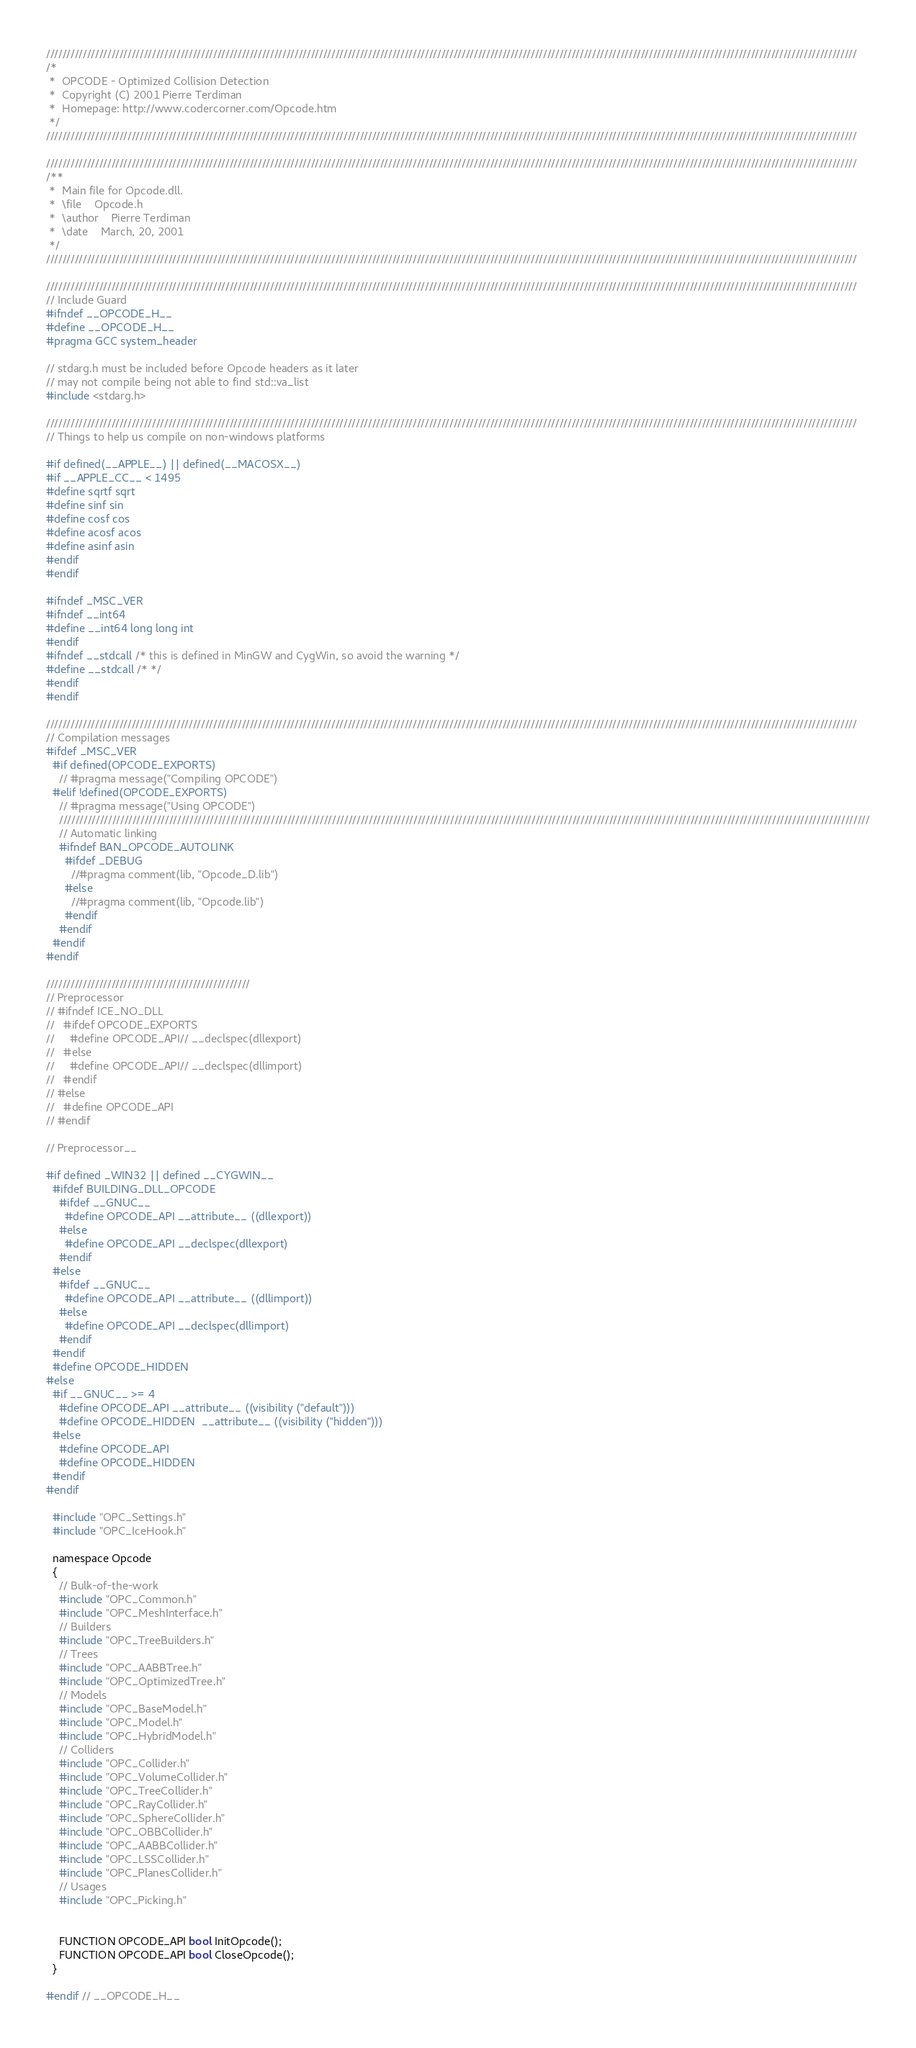Convert code to text. <code><loc_0><loc_0><loc_500><loc_500><_C_>///////////////////////////////////////////////////////////////////////////////////////////////////////////////////////////////////////////////////////////////////////////////////////////////////////
/*
 *  OPCODE - Optimized Collision Detection
 *  Copyright (C) 2001 Pierre Terdiman
 *  Homepage: http://www.codercorner.com/Opcode.htm
 */
///////////////////////////////////////////////////////////////////////////////////////////////////////////////////////////////////////////////////////////////////////////////////////////////////////

///////////////////////////////////////////////////////////////////////////////////////////////////////////////////////////////////////////////////////////////////////////////////////////////////////
/**
 *  Main file for Opcode.dll.
 *  \file    Opcode.h
 *  \author    Pierre Terdiman
 *  \date    March, 20, 2001
 */
///////////////////////////////////////////////////////////////////////////////////////////////////////////////////////////////////////////////////////////////////////////////////////////////////////

///////////////////////////////////////////////////////////////////////////////////////////////////////////////////////////////////////////////////////////////////////////////////////////////////////
// Include Guard
#ifndef __OPCODE_H__
#define __OPCODE_H__
#pragma GCC system_header

// stdarg.h must be included before Opcode headers as it later
// may not compile being not able to find std::va_list
#include <stdarg.h>

///////////////////////////////////////////////////////////////////////////////////////////////////////////////////////////////////////////////////////////////////////////////////////////////////////
// Things to help us compile on non-windows platforms

#if defined(__APPLE__) || defined(__MACOSX__)
#if __APPLE_CC__ < 1495
#define sqrtf sqrt
#define sinf sin
#define cosf cos
#define acosf acos
#define asinf asin
#endif
#endif

#ifndef _MSC_VER
#ifndef __int64
#define __int64 long long int
#endif
#ifndef __stdcall /* this is defined in MinGW and CygWin, so avoid the warning */
#define __stdcall /* */
#endif
#endif

///////////////////////////////////////////////////////////////////////////////////////////////////////////////////////////////////////////////////////////////////////////////////////////////////////
// Compilation messages
#ifdef _MSC_VER
  #if defined(OPCODE_EXPORTS)
    // #pragma message("Compiling OPCODE")
  #elif !defined(OPCODE_EXPORTS)
    // #pragma message("Using OPCODE")
    ///////////////////////////////////////////////////////////////////////////////////////////////////////////////////////////////////////////////////////////////////////////////////////////////////////
    // Automatic linking
    #ifndef BAN_OPCODE_AUTOLINK
      #ifdef _DEBUG
        //#pragma comment(lib, "Opcode_D.lib")
      #else
        //#pragma comment(lib, "Opcode.lib")
      #endif
    #endif
  #endif
#endif

//////////////////////////////////////////////////
// Preprocessor
// #ifndef ICE_NO_DLL
//   #ifdef OPCODE_EXPORTS
//     #define OPCODE_API// __declspec(dllexport)
//   #else
//     #define OPCODE_API// __declspec(dllimport)
//   #endif
// #else
//   #define OPCODE_API
// #endif

// Preprocessor__

#if defined _WIN32 || defined __CYGWIN__
  #ifdef BUILDING_DLL_OPCODE
    #ifdef __GNUC__
      #define OPCODE_API __attribute__ ((dllexport))
    #else
      #define OPCODE_API __declspec(dllexport)
    #endif
  #else
    #ifdef __GNUC__
      #define OPCODE_API __attribute__ ((dllimport))
    #else
      #define OPCODE_API __declspec(dllimport)
    #endif
  #endif
  #define OPCODE_HIDDEN
#else
  #if __GNUC__ >= 4
    #define OPCODE_API __attribute__ ((visibility ("default")))
    #define OPCODE_HIDDEN  __attribute__ ((visibility ("hidden")))
  #else
    #define OPCODE_API
    #define OPCODE_HIDDEN
  #endif
#endif

  #include "OPC_Settings.h"
  #include "OPC_IceHook.h"

  namespace Opcode
  {
    // Bulk-of-the-work
    #include "OPC_Common.h"
    #include "OPC_MeshInterface.h"
    // Builders
    #include "OPC_TreeBuilders.h"
    // Trees
    #include "OPC_AABBTree.h"
    #include "OPC_OptimizedTree.h"
    // Models
    #include "OPC_BaseModel.h"
    #include "OPC_Model.h"
    #include "OPC_HybridModel.h"
    // Colliders
    #include "OPC_Collider.h"
    #include "OPC_VolumeCollider.h"
    #include "OPC_TreeCollider.h"
    #include "OPC_RayCollider.h"
    #include "OPC_SphereCollider.h"
    #include "OPC_OBBCollider.h"
    #include "OPC_AABBCollider.h"
    #include "OPC_LSSCollider.h"
    #include "OPC_PlanesCollider.h"
    // Usages
    #include "OPC_Picking.h"


    FUNCTION OPCODE_API bool InitOpcode();
    FUNCTION OPCODE_API bool CloseOpcode();
  }

#endif // __OPCODE_H__
</code> 